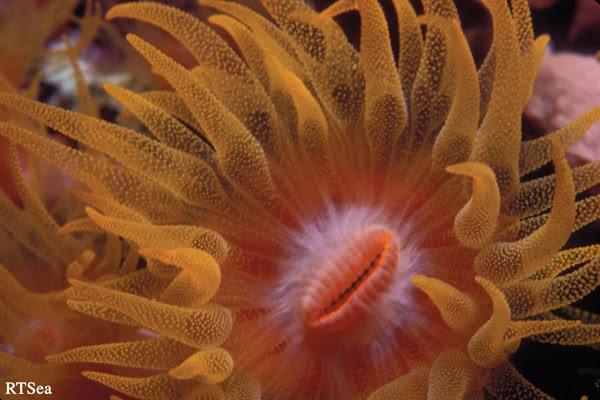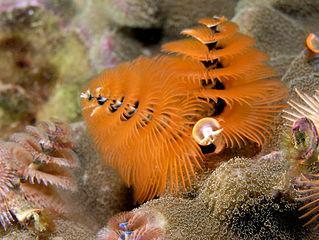The first image is the image on the left, the second image is the image on the right. Assess this claim about the two images: "The left image contains one anemone, which has orangish color, tapered tendrils, and a darker center with a """"mouth"""" opening.". Correct or not? Answer yes or no. Yes. 